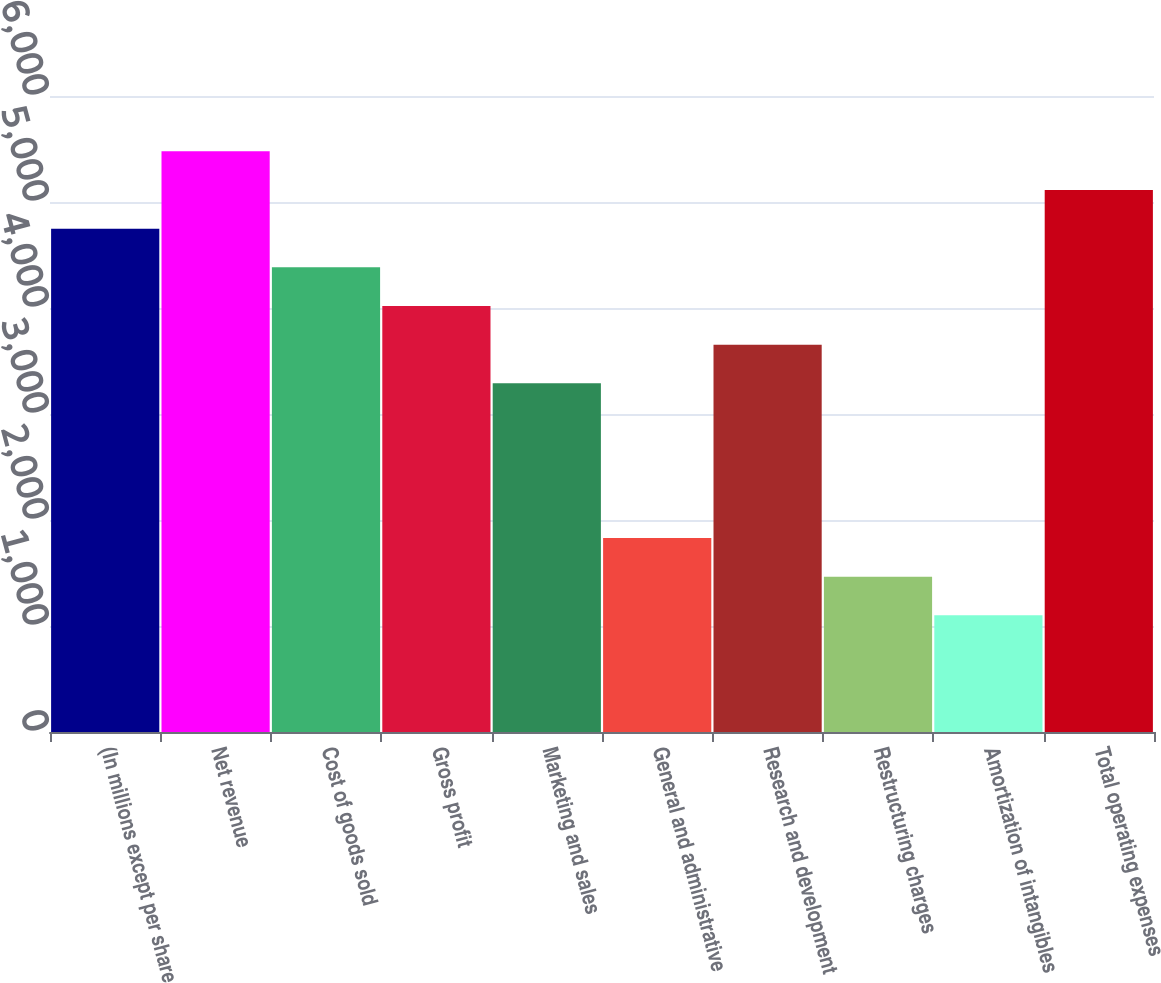Convert chart to OTSL. <chart><loc_0><loc_0><loc_500><loc_500><bar_chart><fcel>(In millions except per share<fcel>Net revenue<fcel>Cost of goods sold<fcel>Gross profit<fcel>Marketing and sales<fcel>General and administrative<fcel>Research and development<fcel>Restructuring charges<fcel>Amortization of intangibles<fcel>Total operating expenses<nl><fcel>4748.4<fcel>5478<fcel>4383.6<fcel>4018.8<fcel>3289.2<fcel>1830<fcel>3654<fcel>1465.2<fcel>1100.4<fcel>5113.2<nl></chart> 